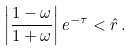<formula> <loc_0><loc_0><loc_500><loc_500>\left | \frac { 1 - \omega } { 1 + \omega } \right | e ^ { - \tau } < \hat { r } \, .</formula> 